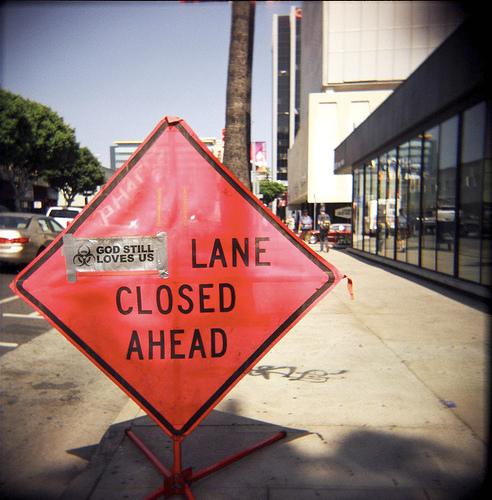What color is the car on the street?
Keep it brief. Gold. What shape is the sign?
Short answer required. Diamond. What is used to cover up the words on the sign?
Write a very short answer. Sticker. 